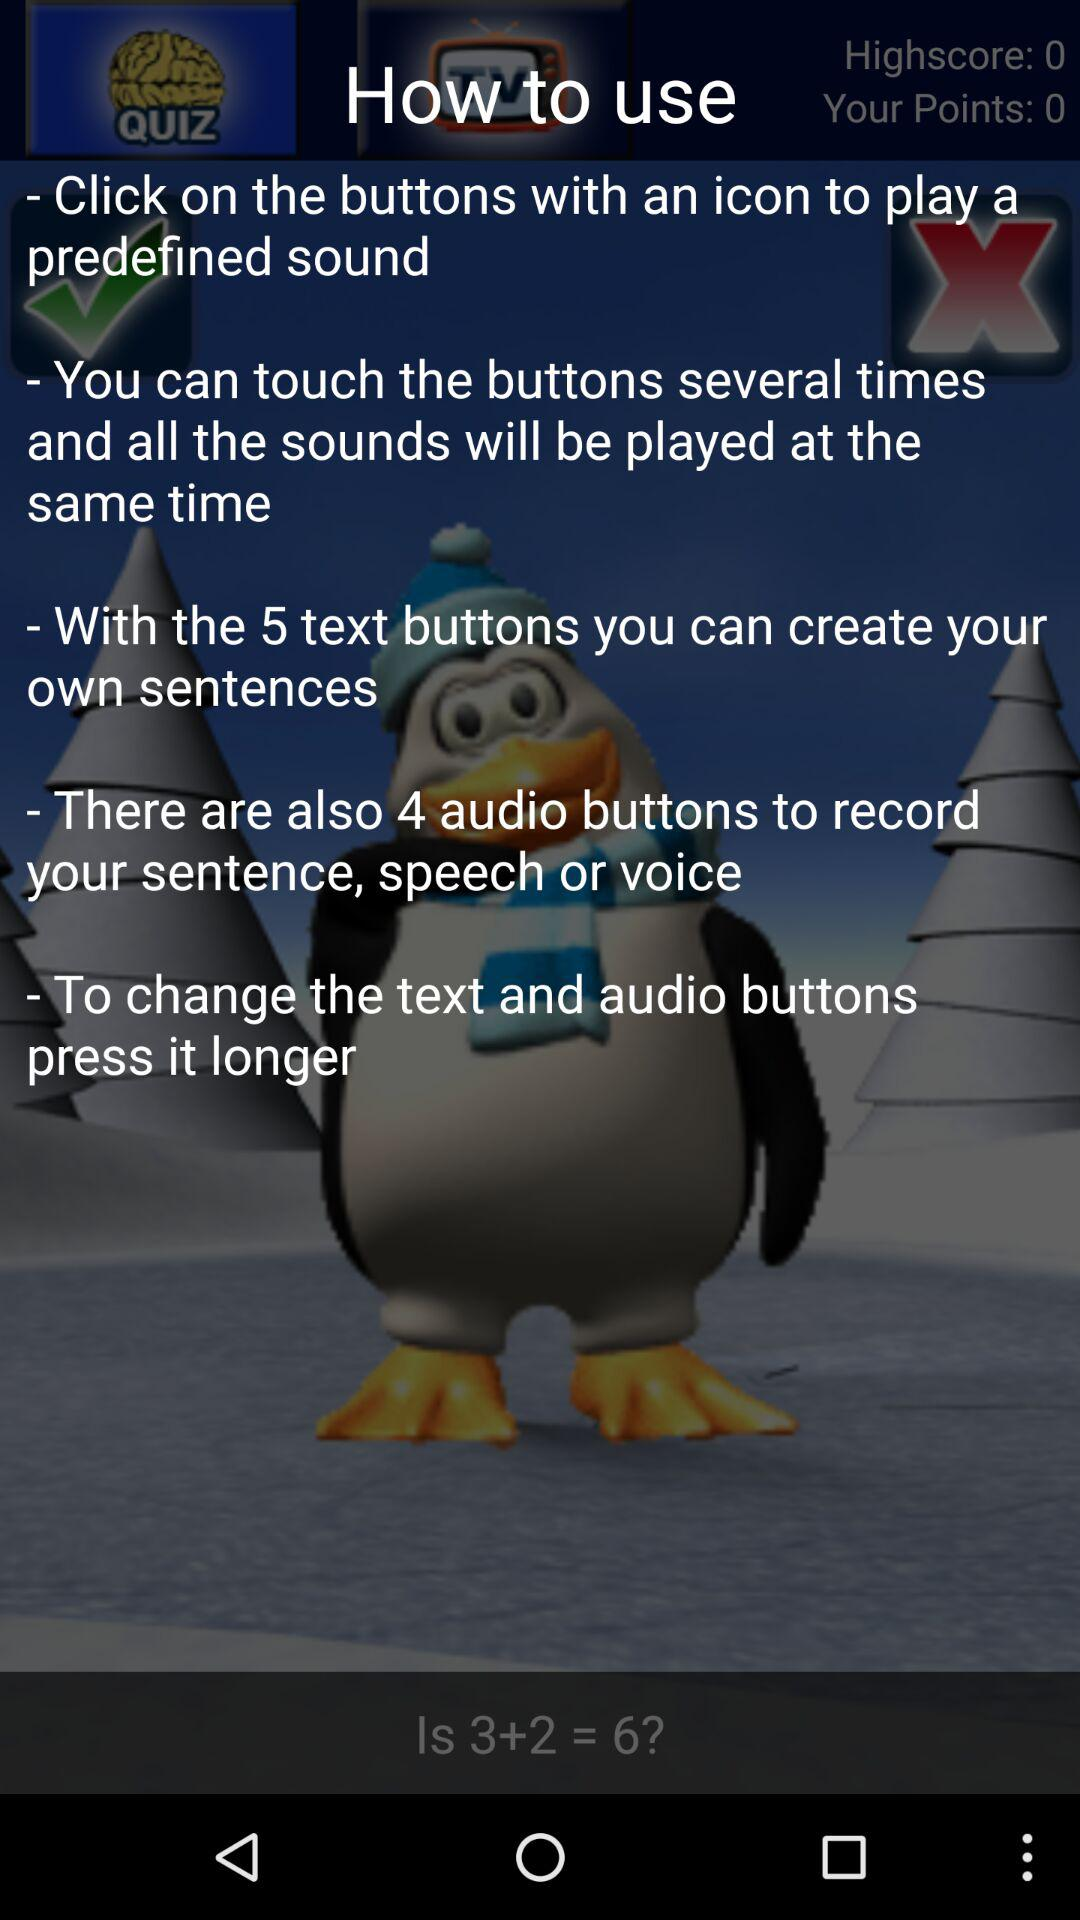What should we do to change the test and audio buttons? We should press it longer. 